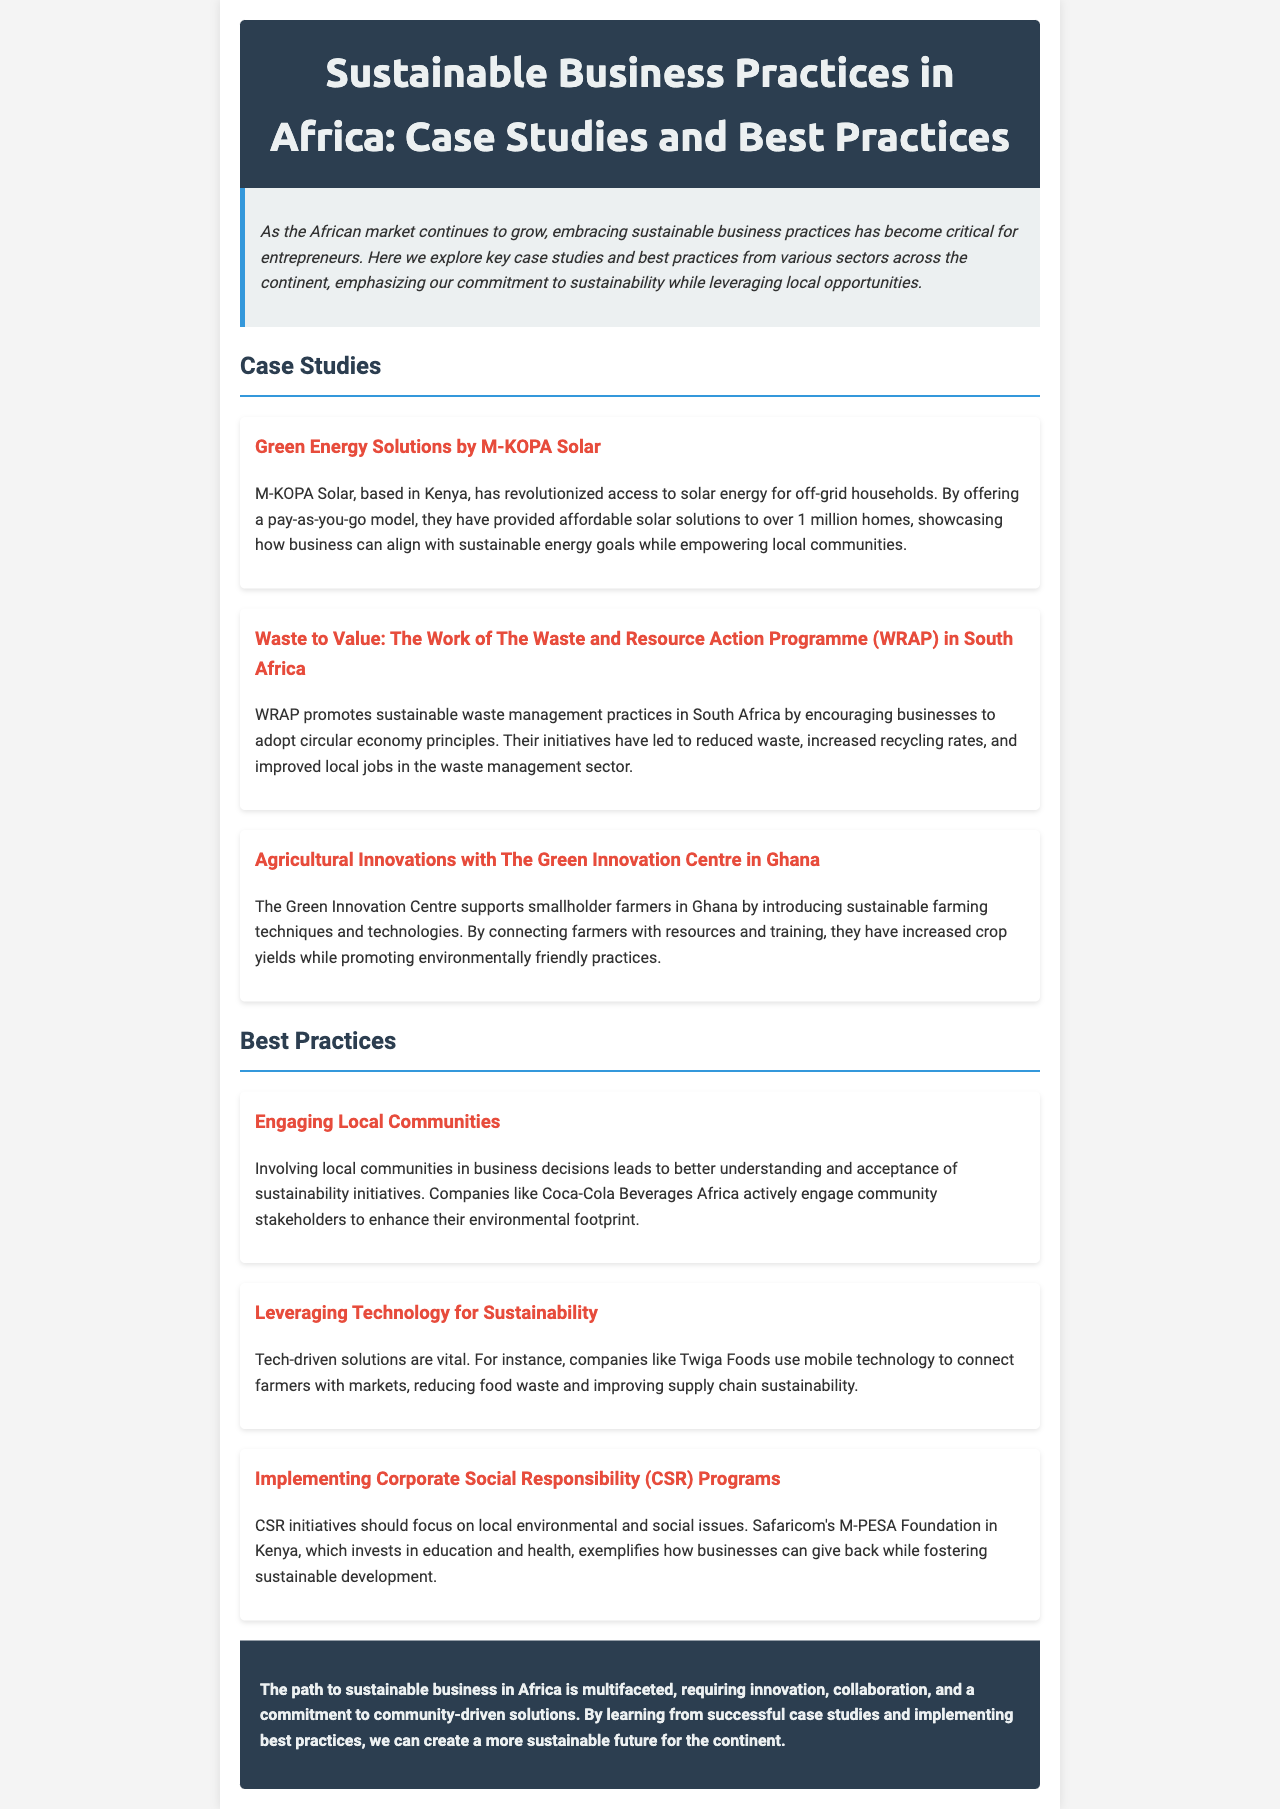What is the title of the newsletter? The title of the newsletter is found in the header section of the document.
Answer: Sustainable Business Practices in Africa: Case Studies and Best Practices How many case studies are presented in the document? The document lists three specific case studies in the "Case Studies" section.
Answer: 3 What innovative payment model does M-KOPA Solar use? The document mentions the payment model utilized by M-KOPA Solar.
Answer: pay-as-you-go Which organization promotes sustainable waste management in South Africa? The document explicitly states the name of the organization working on waste management in South Africa.
Answer: WRAP What is a best practice mentioned for engaging local communities? The document provides a concise statement regarding community engagement in sustainable initiatives.
Answer: Involving local communities in business decisions Which technology-driven company connects farmers with markets? The document identifies a specific company that utilizes technology for connecting farmers with markets.
Answer: Twiga Foods What does Safaricom's M-PESA Foundation invest in? The document highlights the focus areas of Safaricom's CSR initiatives.
Answer: education and health What is emphasized as critical for entrepreneurs in Africa? The document reflects on the significance of a specific aspect for entrepreneurs within the growth of the African market.
Answer: embracing sustainable business practices 